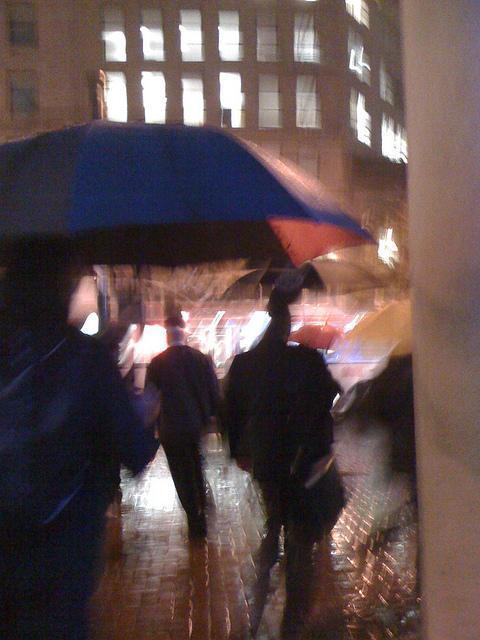How many umbrellas are there?
Give a very brief answer. 2. How many people are there?
Give a very brief answer. 3. How many bicycles are there?
Give a very brief answer. 0. 